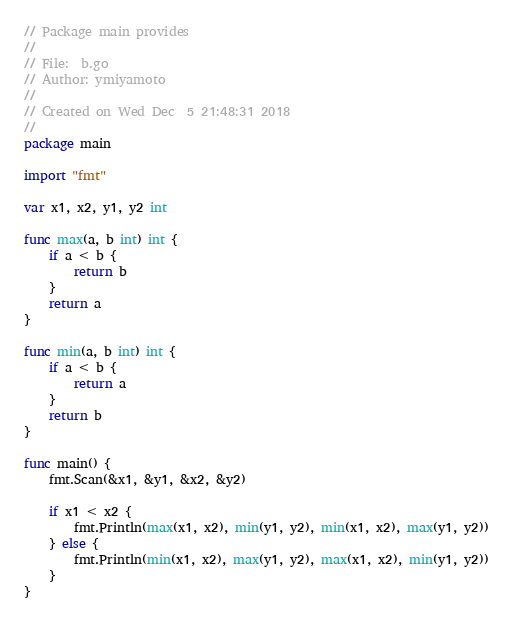Convert code to text. <code><loc_0><loc_0><loc_500><loc_500><_Go_>// Package main provides
//
// File:  b.go
// Author: ymiyamoto
//
// Created on Wed Dec  5 21:48:31 2018
//
package main

import "fmt"

var x1, x2, y1, y2 int

func max(a, b int) int {
	if a < b {
		return b
	}
	return a
}

func min(a, b int) int {
	if a < b {
		return a
	}
	return b
}

func main() {
	fmt.Scan(&x1, &y1, &x2, &y2)

	if x1 < x2 {
		fmt.Println(max(x1, x2), min(y1, y2), min(x1, x2), max(y1, y2))
	} else {
		fmt.Println(min(x1, x2), max(y1, y2), max(x1, x2), min(y1, y2))
	}
}
</code> 